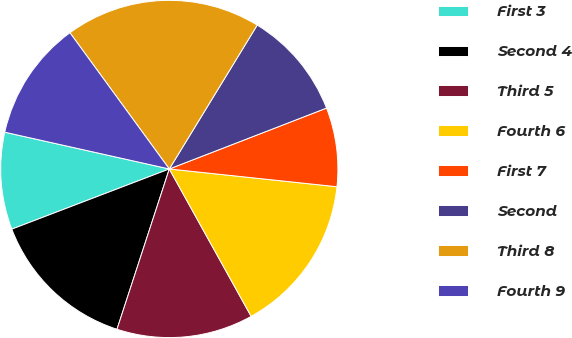<chart> <loc_0><loc_0><loc_500><loc_500><pie_chart><fcel>First 3<fcel>Second 4<fcel>Third 5<fcel>Fourth 6<fcel>First 7<fcel>Second<fcel>Third 8<fcel>Fourth 9<nl><fcel>9.31%<fcel>14.17%<fcel>13.09%<fcel>15.25%<fcel>7.56%<fcel>10.39%<fcel>18.76%<fcel>11.47%<nl></chart> 